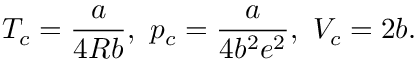Convert formula to latex. <formula><loc_0><loc_0><loc_500><loc_500>T _ { c } = { \frac { a } { 4 R b } } , \ p _ { c } = { \frac { a } { 4 b ^ { 2 } e ^ { 2 } } } , \ V _ { c } = 2 b .</formula> 